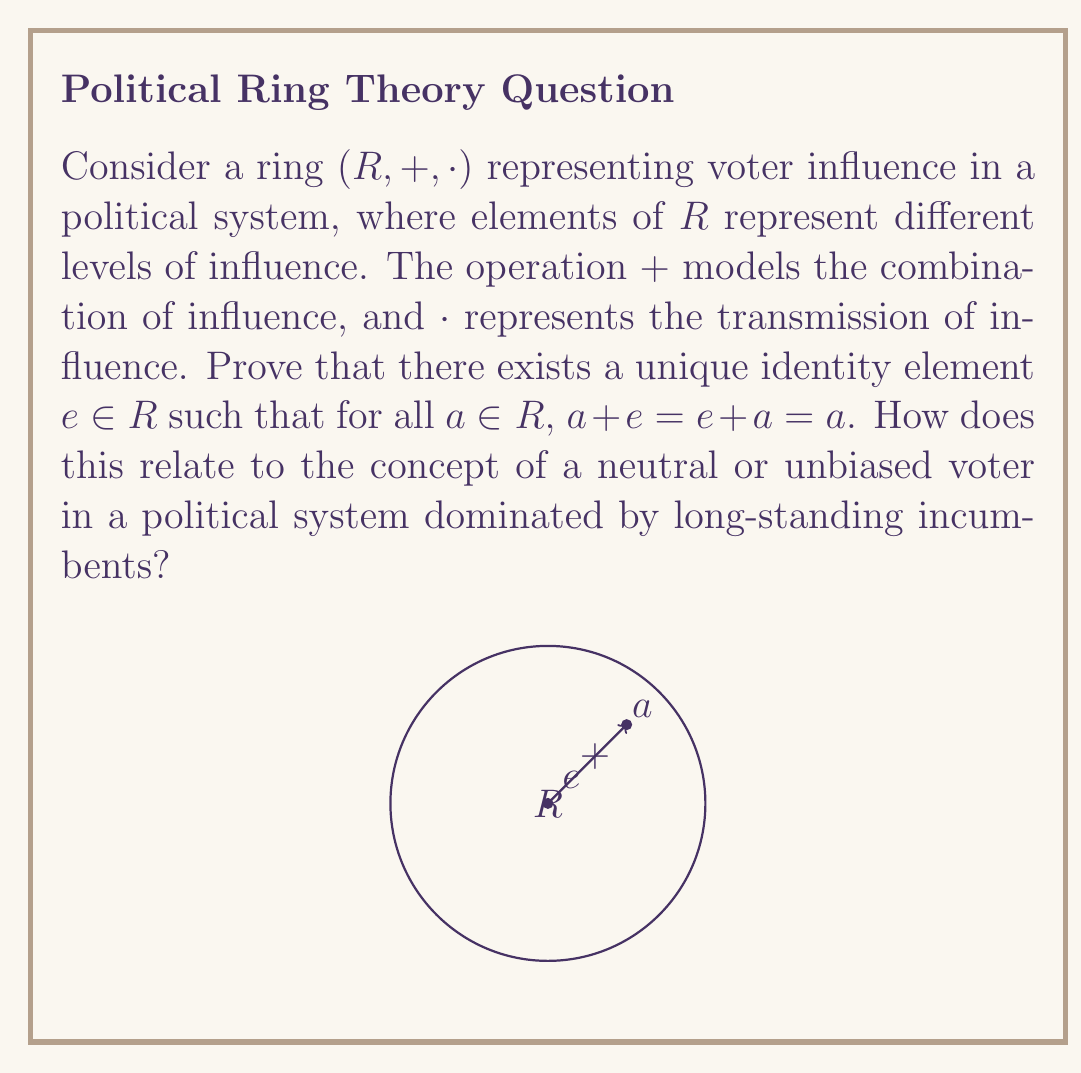Solve this math problem. To prove the existence and uniqueness of the identity element in the ring $(R, +, \cdot)$, we'll follow these steps:

1) Existence:
   Let $a$ be any element in $R$. Consider the equation:
   $$ x + a = a $$
   This equation must have a solution in $R$, say $e_a$, because $R$ is a ring and therefore closed under addition.

2) Right identity property:
   We've found $e_a$ such that $e_a + a = a$. This holds for our chosen $a$.

3) Left identity property:
   Now, we need to show that $a + e_a = a$. 
   Consider: $a + e_a + a = (a + e_a) + a = a + a$
   Subtracting $a$ from both sides (which is possible in a ring):
   $a + e_a = a$

4) Universal property:
   We need to show that $e_a$ works for all elements in $R$, not just $a$.
   Let $b$ be any element in $R$. Then:
   $b + e_a = b + (e_a + a) - a = (b + e_a + a) - a = (b + a) - a = b$

5) Uniqueness:
   Suppose there's another identity element $e'$. Then:
   $e_a = e_a + e' = e'$

Therefore, we've proven the existence and uniqueness of the identity element $e$ in $R$.

In the context of voter influence, this identity element $e$ represents a neutral or unbiased voter. The existence and uniqueness of $e$ suggest that in any political system, there's always a baseline of neutral influence. This concept challenges the idea of complete dominance by long-standing incumbents, as it implies there's always a reference point of neutrality in the system.
Answer: The unique identity element $e$ exists and represents neutral influence in the political system. 